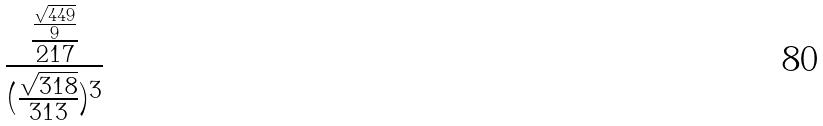Convert formula to latex. <formula><loc_0><loc_0><loc_500><loc_500>\frac { \frac { \frac { \sqrt { 4 4 9 } } { 9 } } { 2 1 7 } } { ( \frac { \sqrt { 3 1 8 } } { 3 1 3 } ) ^ { 3 } }</formula> 